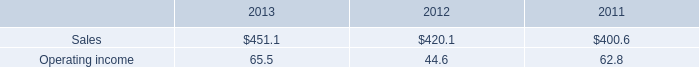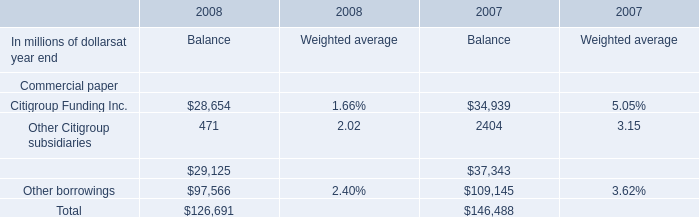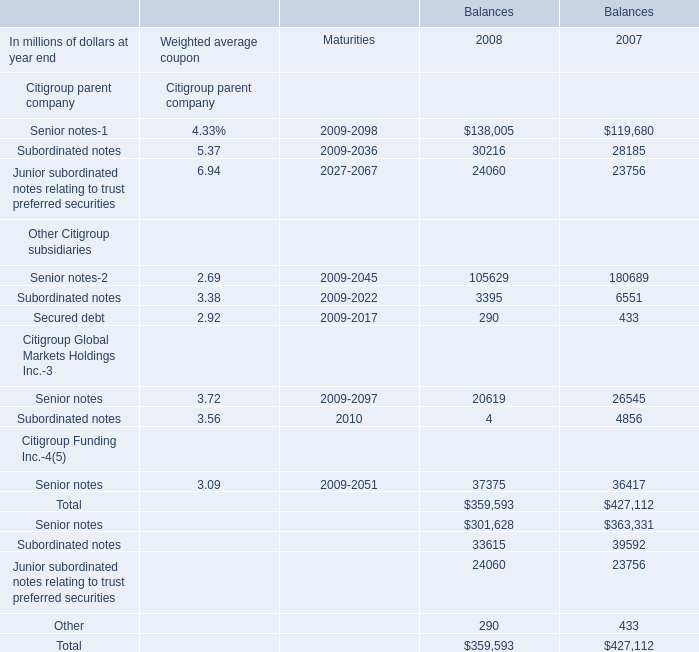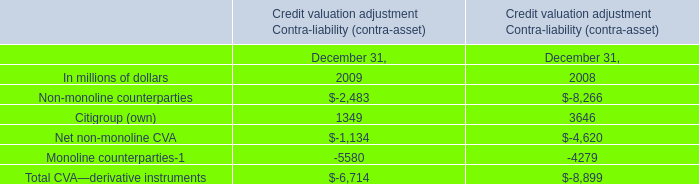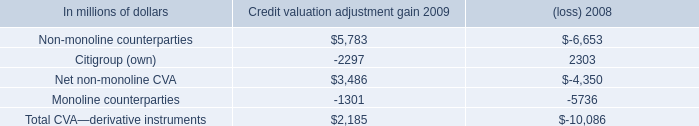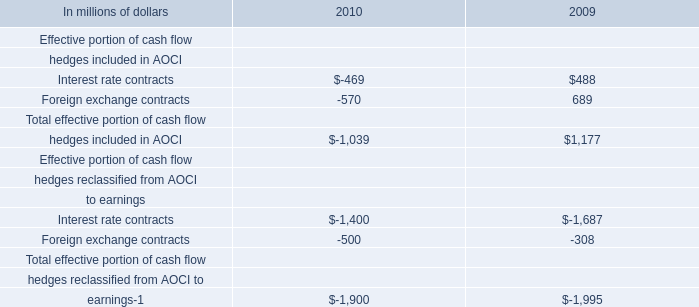Which year is Citigroup Funding Inc. the least for Balance? 
Answer: 2008. 